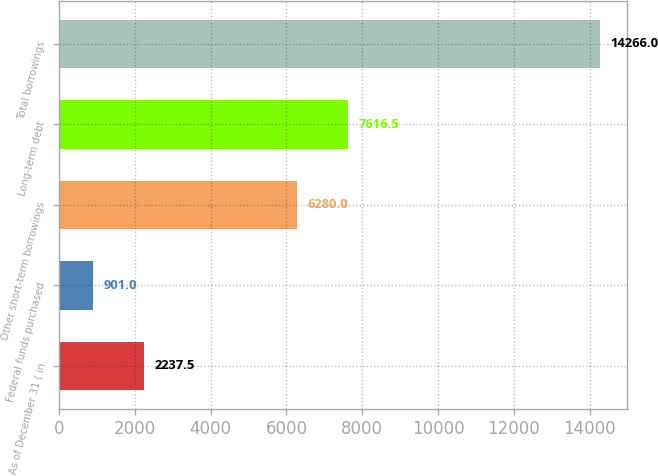Convert chart to OTSL. <chart><loc_0><loc_0><loc_500><loc_500><bar_chart><fcel>As of December 31 ( in<fcel>Federal funds purchased<fcel>Other short-term borrowings<fcel>Long-term debt<fcel>Total borrowings<nl><fcel>2237.5<fcel>901<fcel>6280<fcel>7616.5<fcel>14266<nl></chart> 